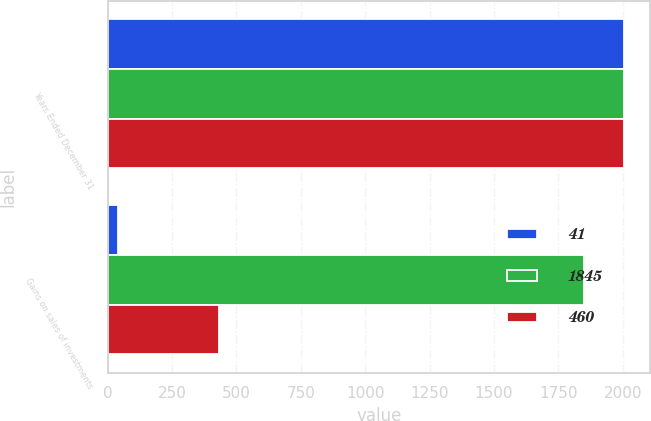<chart> <loc_0><loc_0><loc_500><loc_500><stacked_bar_chart><ecel><fcel>Years Ended December 31<fcel>Gains on sales of investments<nl><fcel>41<fcel>2006<fcel>41<nl><fcel>1845<fcel>2005<fcel>1848<nl><fcel>460<fcel>2004<fcel>434<nl></chart> 